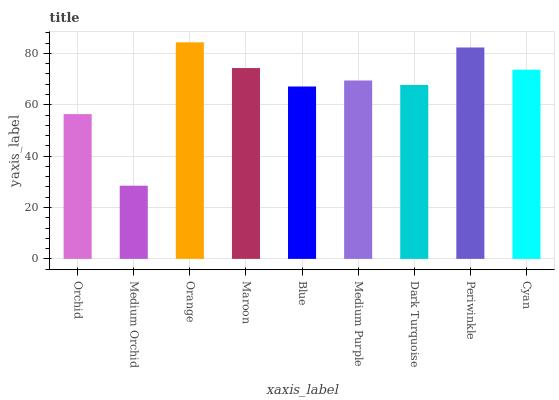Is Orange the minimum?
Answer yes or no. No. Is Medium Orchid the maximum?
Answer yes or no. No. Is Orange greater than Medium Orchid?
Answer yes or no. Yes. Is Medium Orchid less than Orange?
Answer yes or no. Yes. Is Medium Orchid greater than Orange?
Answer yes or no. No. Is Orange less than Medium Orchid?
Answer yes or no. No. Is Medium Purple the high median?
Answer yes or no. Yes. Is Medium Purple the low median?
Answer yes or no. Yes. Is Dark Turquoise the high median?
Answer yes or no. No. Is Dark Turquoise the low median?
Answer yes or no. No. 